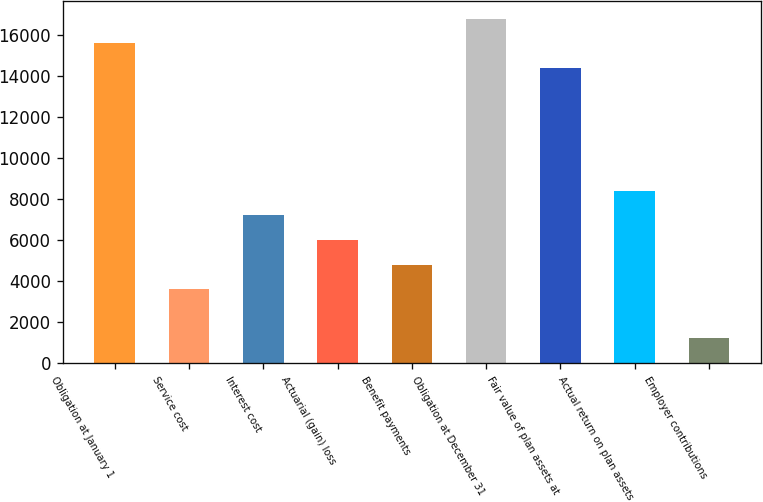<chart> <loc_0><loc_0><loc_500><loc_500><bar_chart><fcel>Obligation at January 1<fcel>Service cost<fcel>Interest cost<fcel>Actuarial (gain) loss<fcel>Benefit payments<fcel>Obligation at December 31<fcel>Fair value of plan assets at<fcel>Actual return on plan assets<fcel>Employer contributions<nl><fcel>15601.2<fcel>3607.2<fcel>7205.4<fcel>6006<fcel>4806.6<fcel>16800.6<fcel>14401.8<fcel>8404.8<fcel>1208.4<nl></chart> 